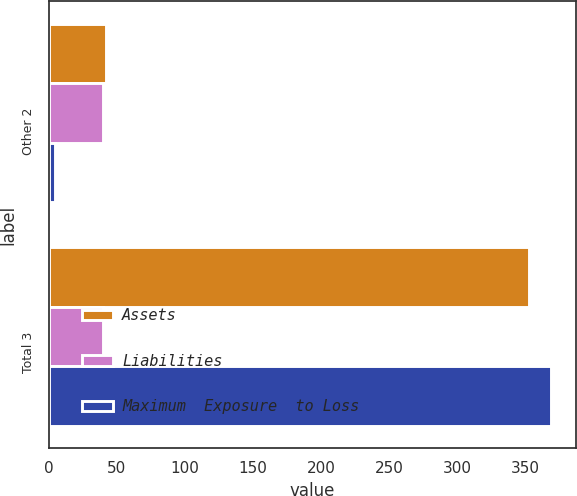Convert chart. <chart><loc_0><loc_0><loc_500><loc_500><stacked_bar_chart><ecel><fcel>Other 2<fcel>Total 3<nl><fcel>Assets<fcel>42<fcel>353<nl><fcel>Liabilities<fcel>40<fcel>40<nl><fcel>Maximum  Exposure  to Loss<fcel>5<fcel>369<nl></chart> 